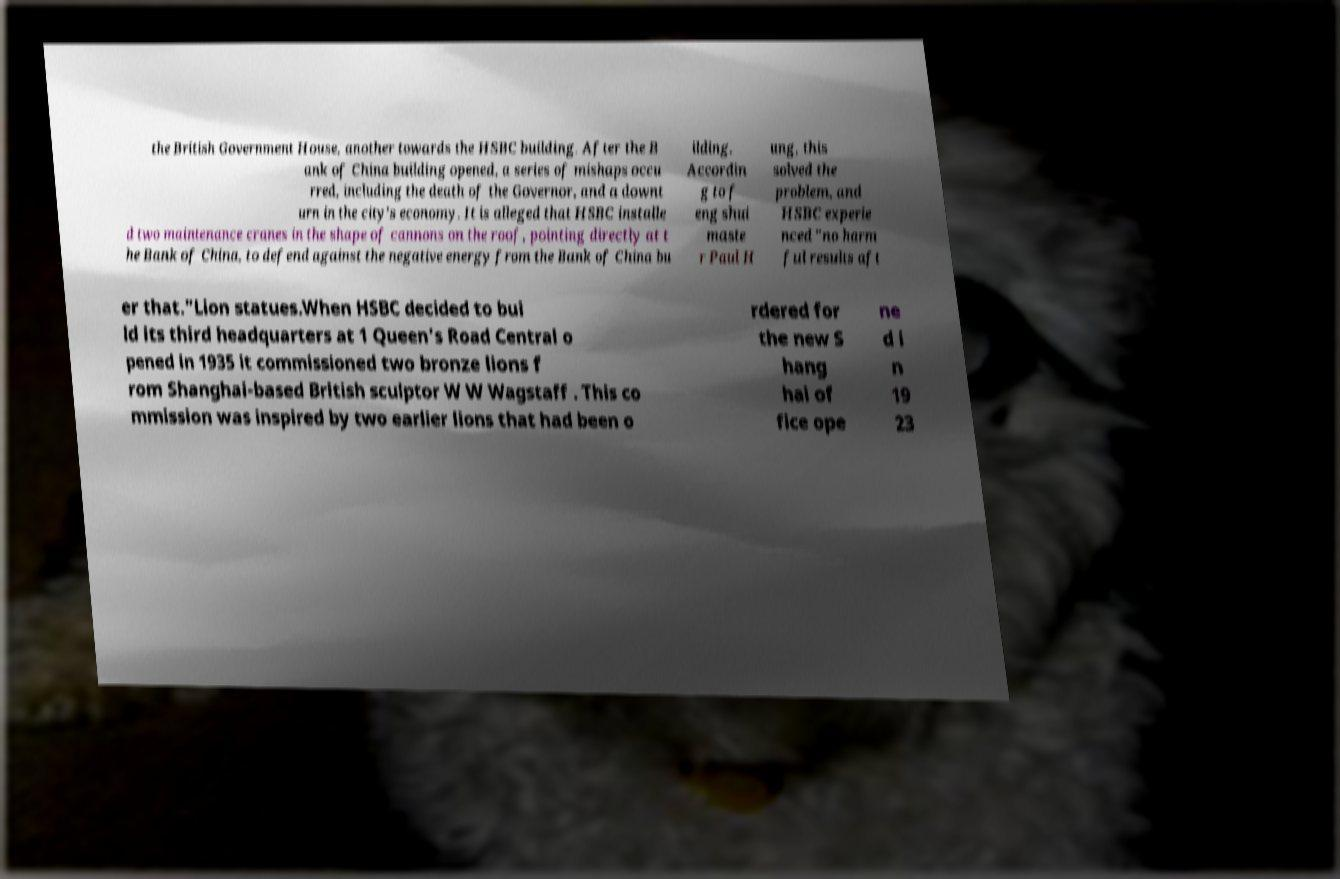Can you accurately transcribe the text from the provided image for me? the British Government House, another towards the HSBC building. After the B ank of China building opened, a series of mishaps occu rred, including the death of the Governor, and a downt urn in the city's economy. It is alleged that HSBC installe d two maintenance cranes in the shape of cannons on the roof, pointing directly at t he Bank of China, to defend against the negative energy from the Bank of China bu ilding. Accordin g to f eng shui maste r Paul H ung, this solved the problem, and HSBC experie nced "no harm ful results aft er that."Lion statues.When HSBC decided to bui ld its third headquarters at 1 Queen's Road Central o pened in 1935 it commissioned two bronze lions f rom Shanghai-based British sculptor W W Wagstaff . This co mmission was inspired by two earlier lions that had been o rdered for the new S hang hai of fice ope ne d i n 19 23 